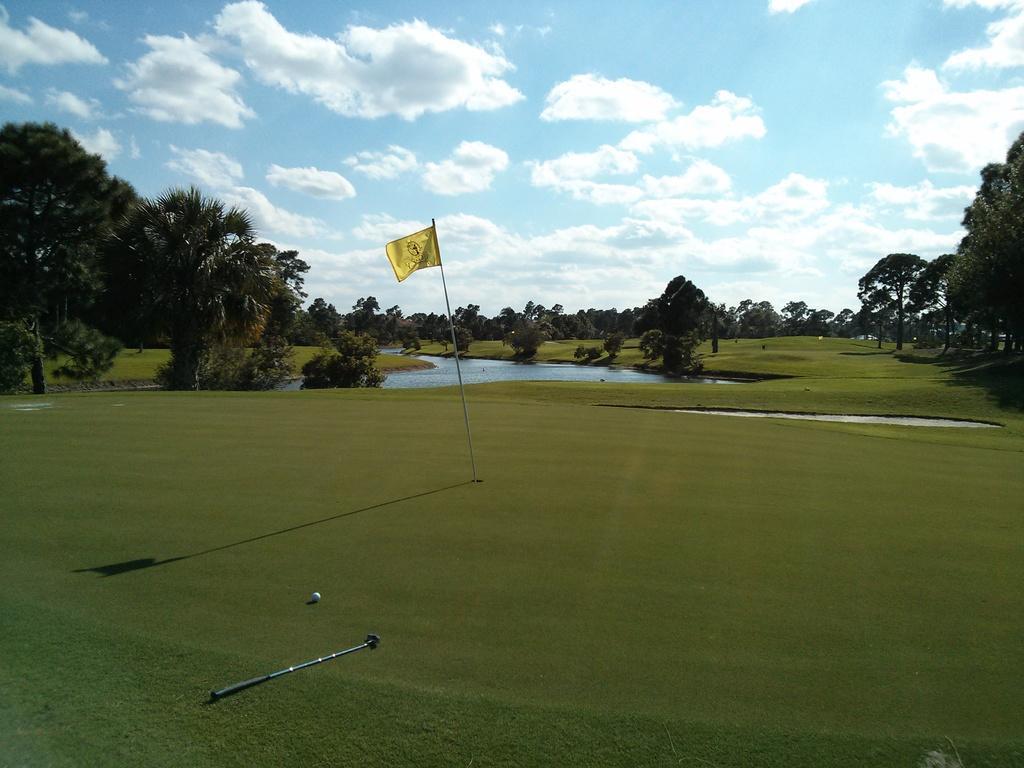Could you give a brief overview of what you see in this image? In this image I can see some grass on the ground, a golf stick, a golf ball and a yellow colored flag on the ground. In the background I can see few trees which are green in color, the water and the sky. 